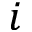<formula> <loc_0><loc_0><loc_500><loc_500>i</formula> 